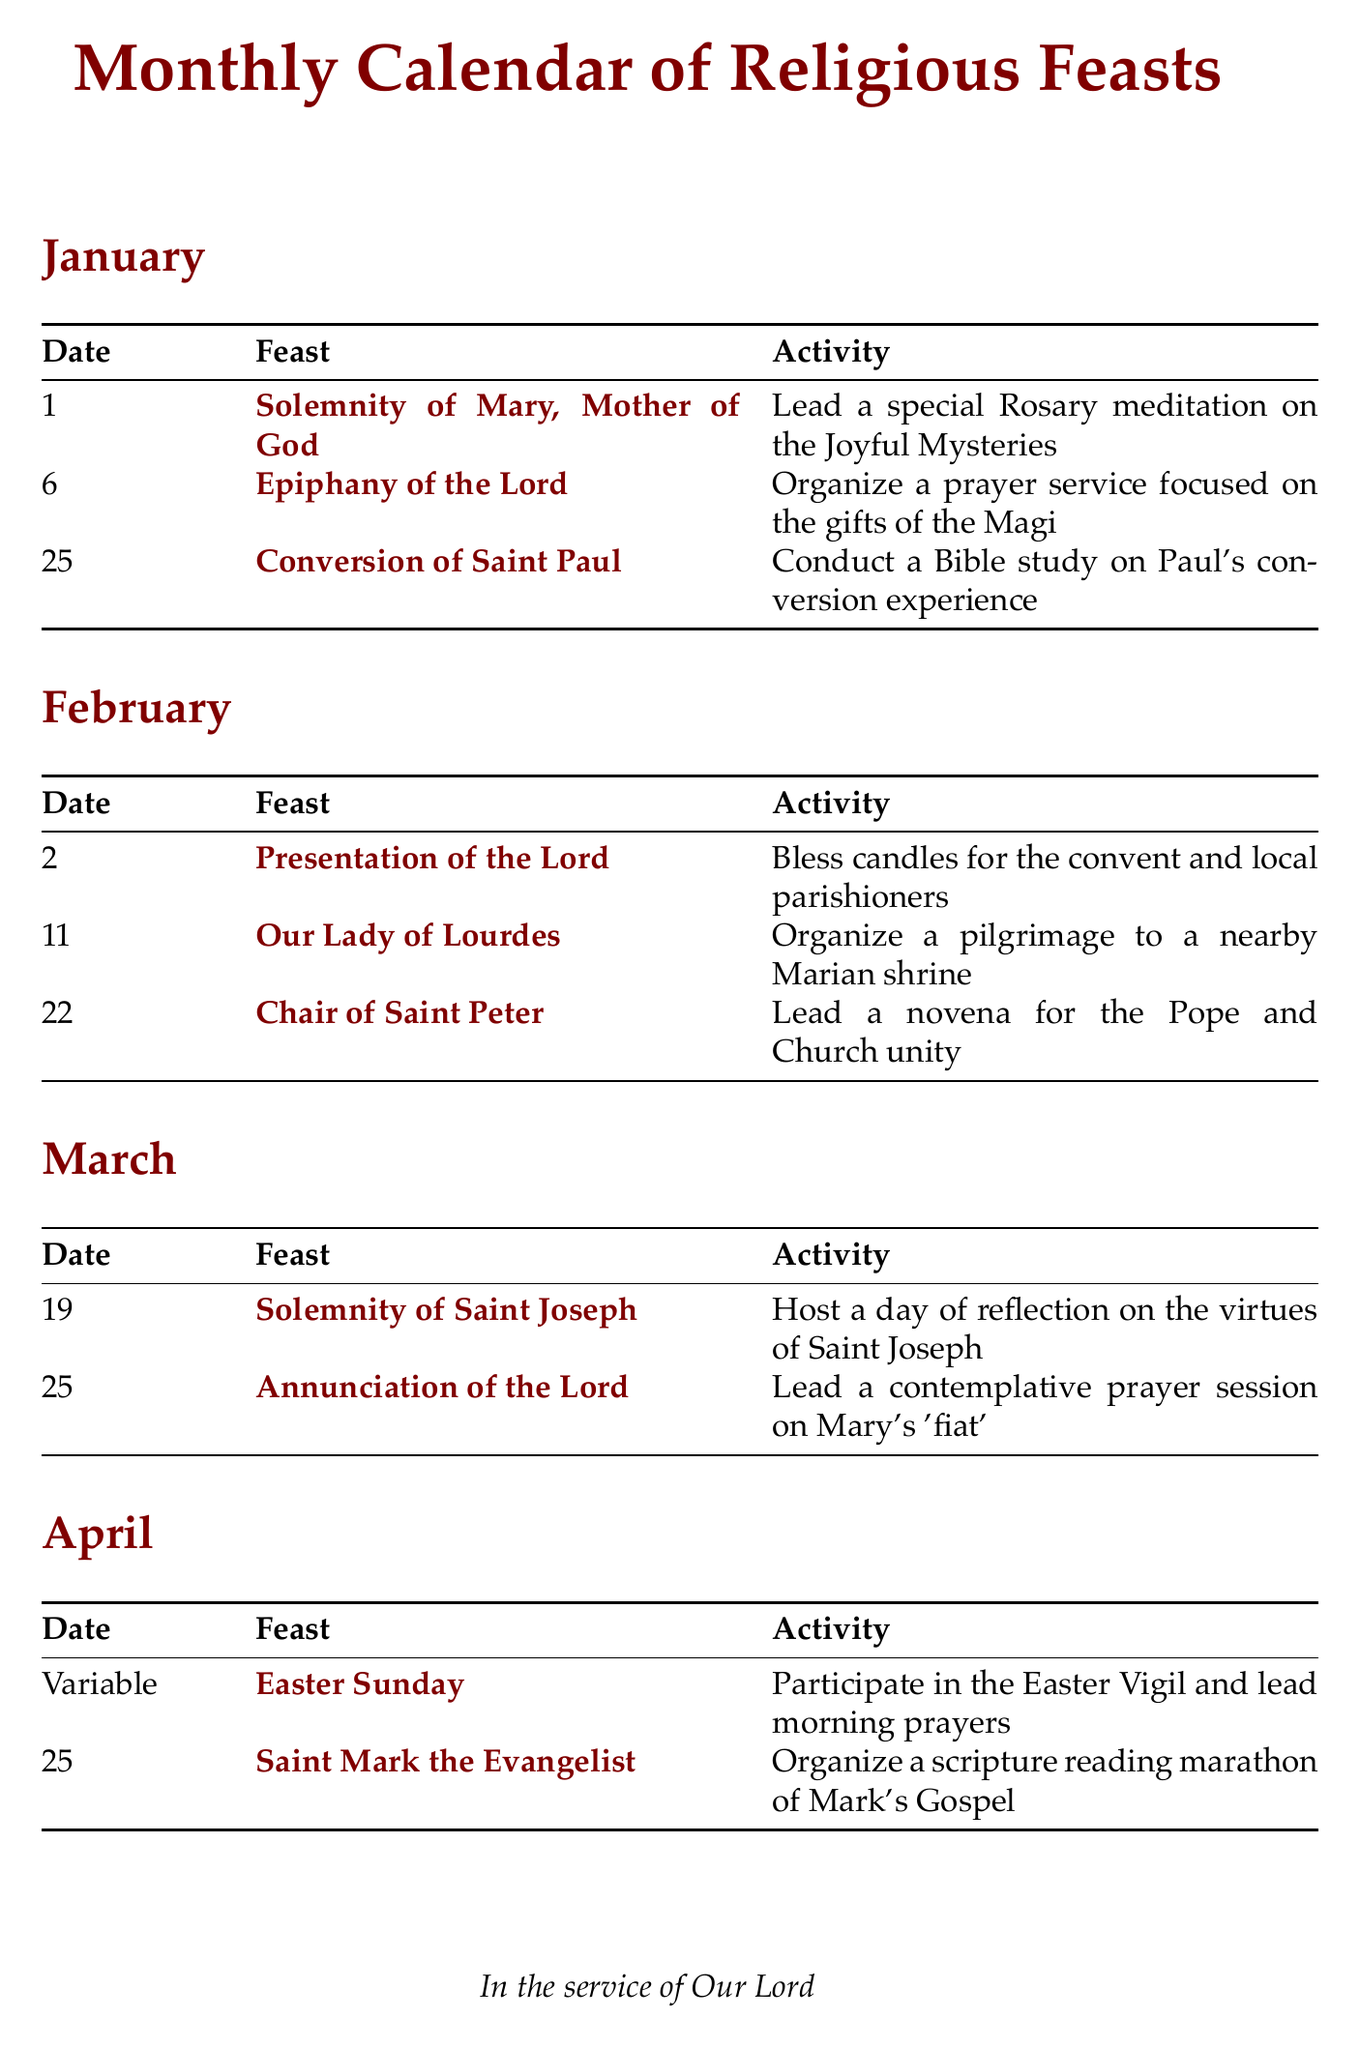what feast is celebrated on January 1? The document lists the feast celebrated on January 1, which is the Solemnity of Mary, Mother of God.
Answer: Solemnity of Mary, Mother of God what activity is organized for the feast of Our Lady of Lourdes on February 11? The document mentions that on February 11, for the feast of Our Lady of Lourdes, a pilgrimage to a nearby Marian shrine is organized.
Answer: Organize a pilgrimage to a nearby Marian shrine which feast occurs on March 19? The feast celebrated on March 19, as per the document, is the Solemnity of Saint Joseph.
Answer: Solemnity of Saint Joseph how many activities are planned for the month of May? By counting the activities listed under May in the document, we see that there are three activities planned.
Answer: 3 what is the date of the Nativity of the Lord? The document specifies that the Nativity of the Lord is celebrated on December 25.
Answer: December 25 which feast has a variable date in April? According to the document, the feast with a variable date in April is Easter Sunday.
Answer: Easter Sunday what special event is held on November 2? The document states that on November 2, prayers are led in the local cemetery for the deceased.
Answer: Lead prayers in the local cemetery for the deceased what is the main focus of the activity on June 29? The document indicates that the main focus of the activity on June 29 is a lecture on the early Church and apostolic tradition.
Answer: Host a lecture on the early Church and apostolic tradition 